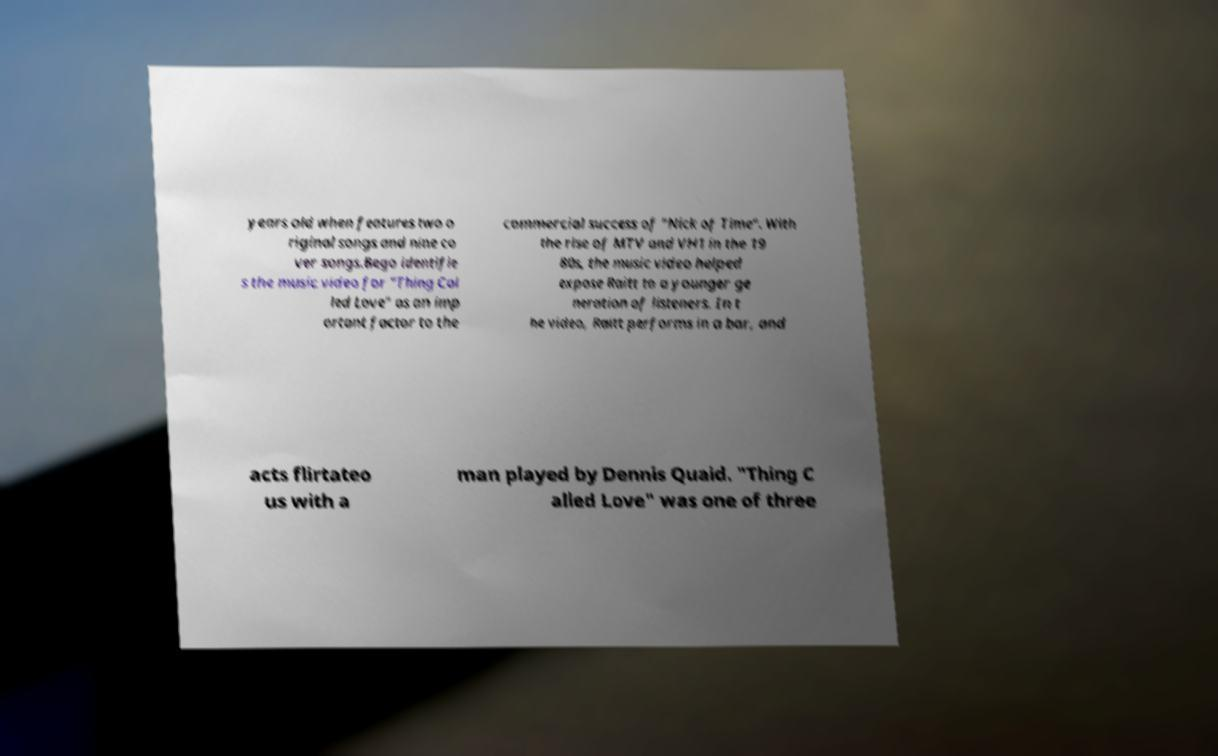Could you extract and type out the text from this image? years old when features two o riginal songs and nine co ver songs.Bego identifie s the music video for "Thing Cal led Love" as an imp ortant factor to the commercial success of "Nick of Time". With the rise of MTV and VH1 in the 19 80s, the music video helped expose Raitt to a younger ge neration of listeners. In t he video, Raitt performs in a bar, and acts flirtateo us with a man played by Dennis Quaid. "Thing C alled Love" was one of three 